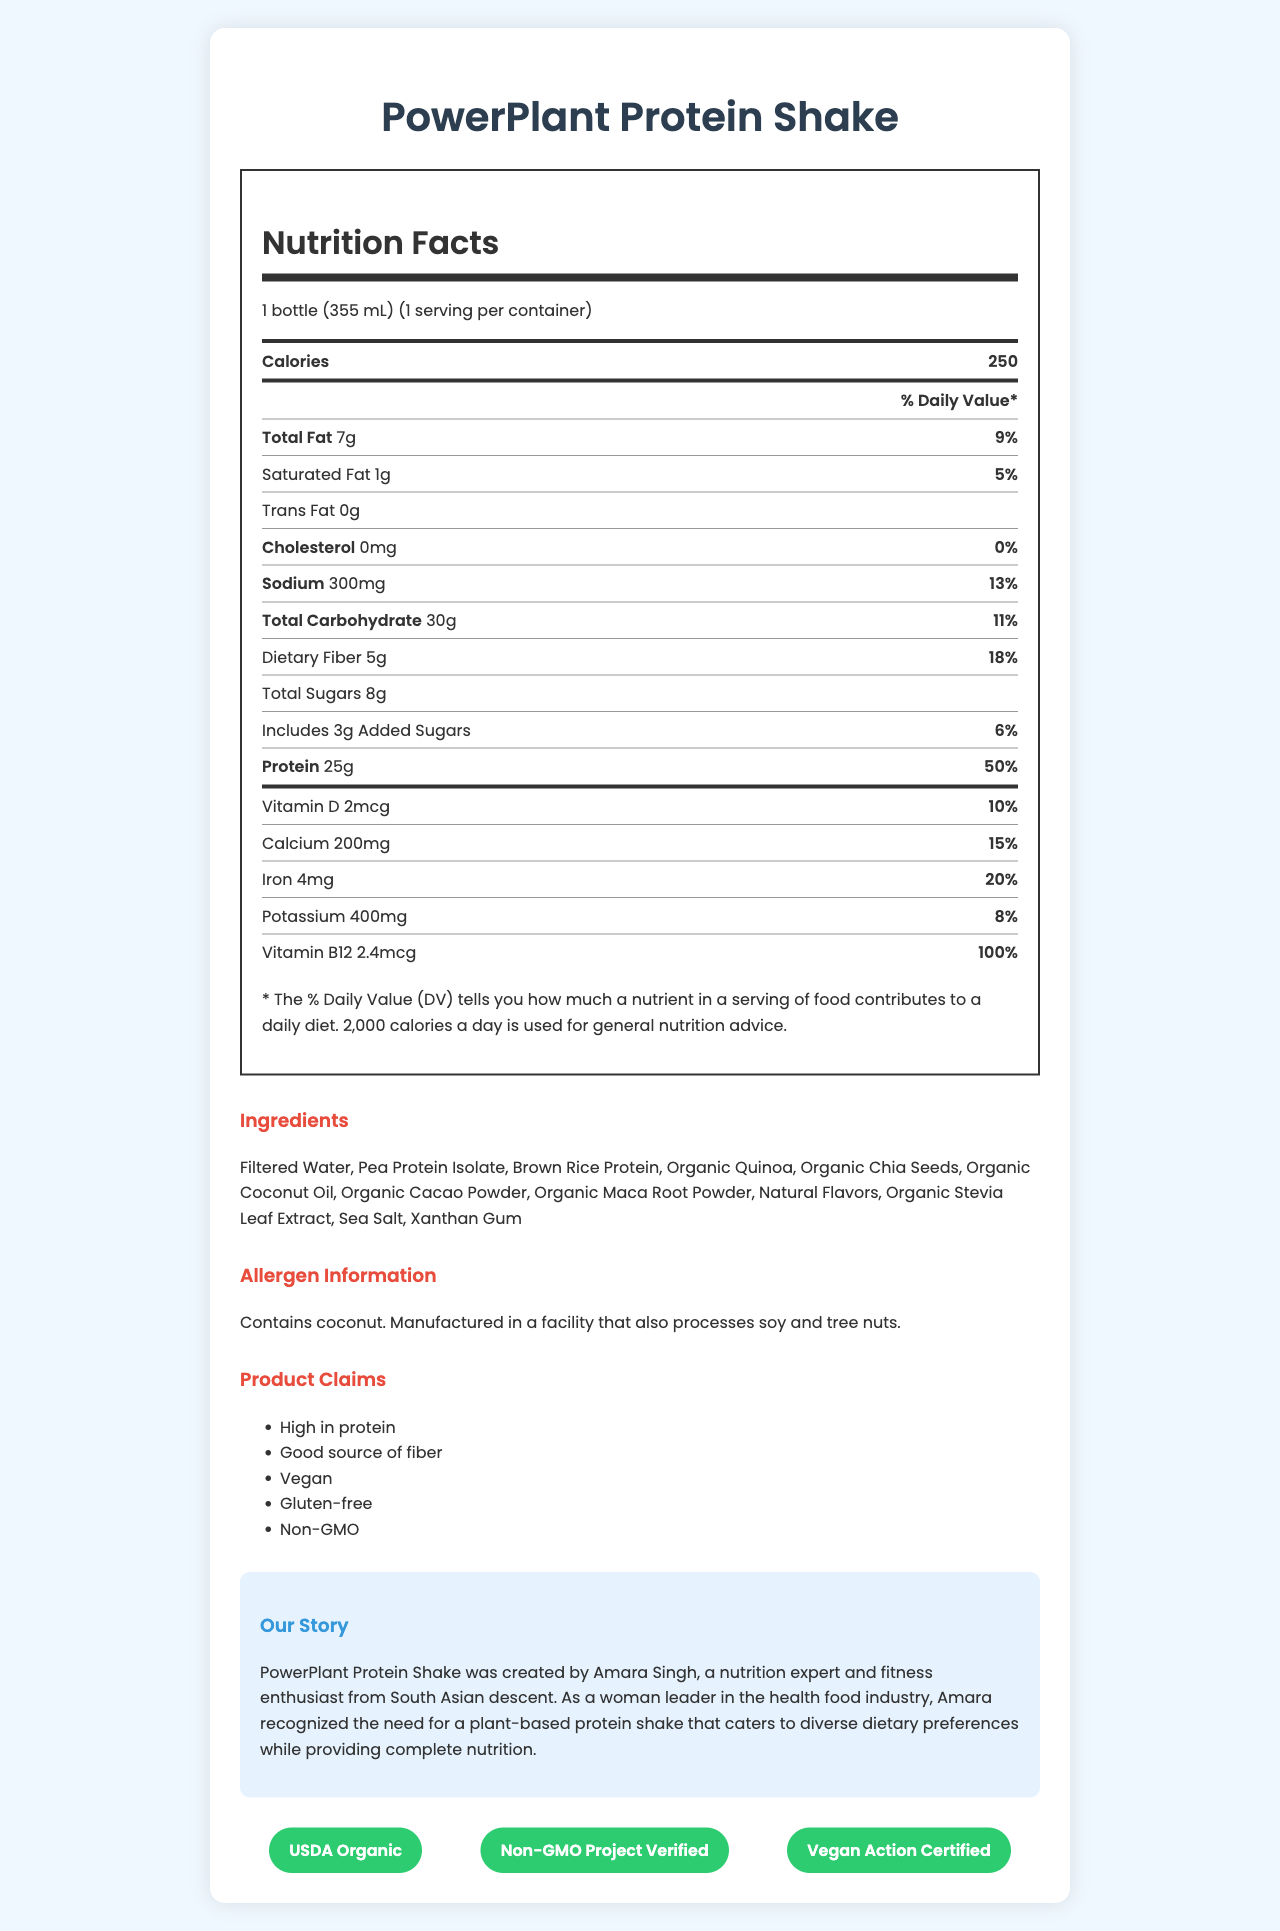what is the total fat content in the shake? The document states that the total fat content is 7 grams.
Answer: 7 grams how many calories are in one serving of the PowerPlant Protein Shake? The document mentions that one serving contains 250 calories.
Answer: 250 calories what percentage of the daily value for protein does one bottle provide? The document states that 25 grams of protein equals 50% of the daily value.
Answer: 50% what is the sodium content in milligrams? The document lists the sodium content as 300 mg.
Answer: 300 mg how many grams of dietary fiber are in the shake? The document indicates that the dietary fiber content is 5 grams.
Answer: 5 grams which vitamin has the highest daily value percentage? A. Vitamin D B. Calcium C. Iron D. Vitamin B12 The document shows that Vitamin B12 has a daily value of 100%, which is the highest among the listed vitamins.
Answer: D. Vitamin B12 what is the serving size of the PowerPlant Protein Shake? A. 250 mL B. 355 mL C. 500 mL D. 375 mL The document specifies that the serving size is 1 bottle (355 mL).
Answer: B. 355 mL does the product contain any cholesterol? The document states that the product contains 0 mg of cholesterol.
Answer: No is the PowerPlant Protein Shake free from added sugars? The document indicates that it includes 3 grams of added sugars.
Answer: No describe the main idea of the document. The document includes comprehensive details about the nutritional content, ingredients, and various certifications and claims of the PowerPlant Protein Shake.
Answer: The document provides the nutrition facts, ingredient list, allergen information, claim statements, brand story, and certifications for the PowerPlant Protein Shake. It highlights its nutritional value, including high protein content and fibers, and claims to be vegan, gluten-free, and non-GMO. who is the founder of PowerPlant Protein Shake? The brand story section of the document mentions that Amara Singh is the founder of PowerPlant Protein Shake.
Answer: Amara Singh how many servings are in one container of the PowerPlant Protein Shake? The document states that there is 1 serving per container.
Answer: 1 what is the amount of iron in the shake? The document lists the iron content as 4 mg.
Answer: 4 mg is the PowerPlant Protein Shake suitable for people with nut allergies? The allergen information states that it contains coconut and is manufactured in a facility that processes soy and tree nuts; therefore, nut-allergic individuals should be cautious.
Answer: Possibly, but caution is advised how much calcium does one bottle contain in milligrams? The document states that the calcium content is 200 mg.
Answer: 200 mg can I find details about the manufacturing process in the document? The document does not provide any information about the manufacturing process.
Answer: Cannot be determined 